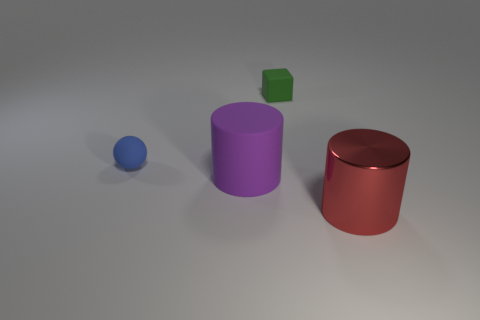What number of other big cylinders are the same material as the purple cylinder?
Provide a succinct answer. 0. What is the size of the cylinder that is to the left of the small green rubber block?
Your response must be concise. Large. The tiny matte thing on the right side of the large cylinder behind the large red metallic cylinder is what shape?
Your answer should be very brief. Cube. What number of small objects are in front of the object in front of the big cylinder on the left side of the green block?
Your response must be concise. 0. Are there fewer blue matte objects behind the red object than large purple matte cylinders?
Ensure brevity in your answer.  No. Is there any other thing that has the same shape as the big shiny thing?
Provide a succinct answer. Yes. The tiny matte object behind the tiny blue thing has what shape?
Provide a short and direct response. Cube. There is a tiny object to the right of the cylinder that is behind the large red cylinder that is right of the tiny blue matte ball; what is its shape?
Your answer should be compact. Cube. How many things are small cyan metal balls or large metallic cylinders?
Offer a terse response. 1. There is a large object that is behind the metal object; does it have the same shape as the big thing that is right of the purple cylinder?
Provide a short and direct response. Yes. 